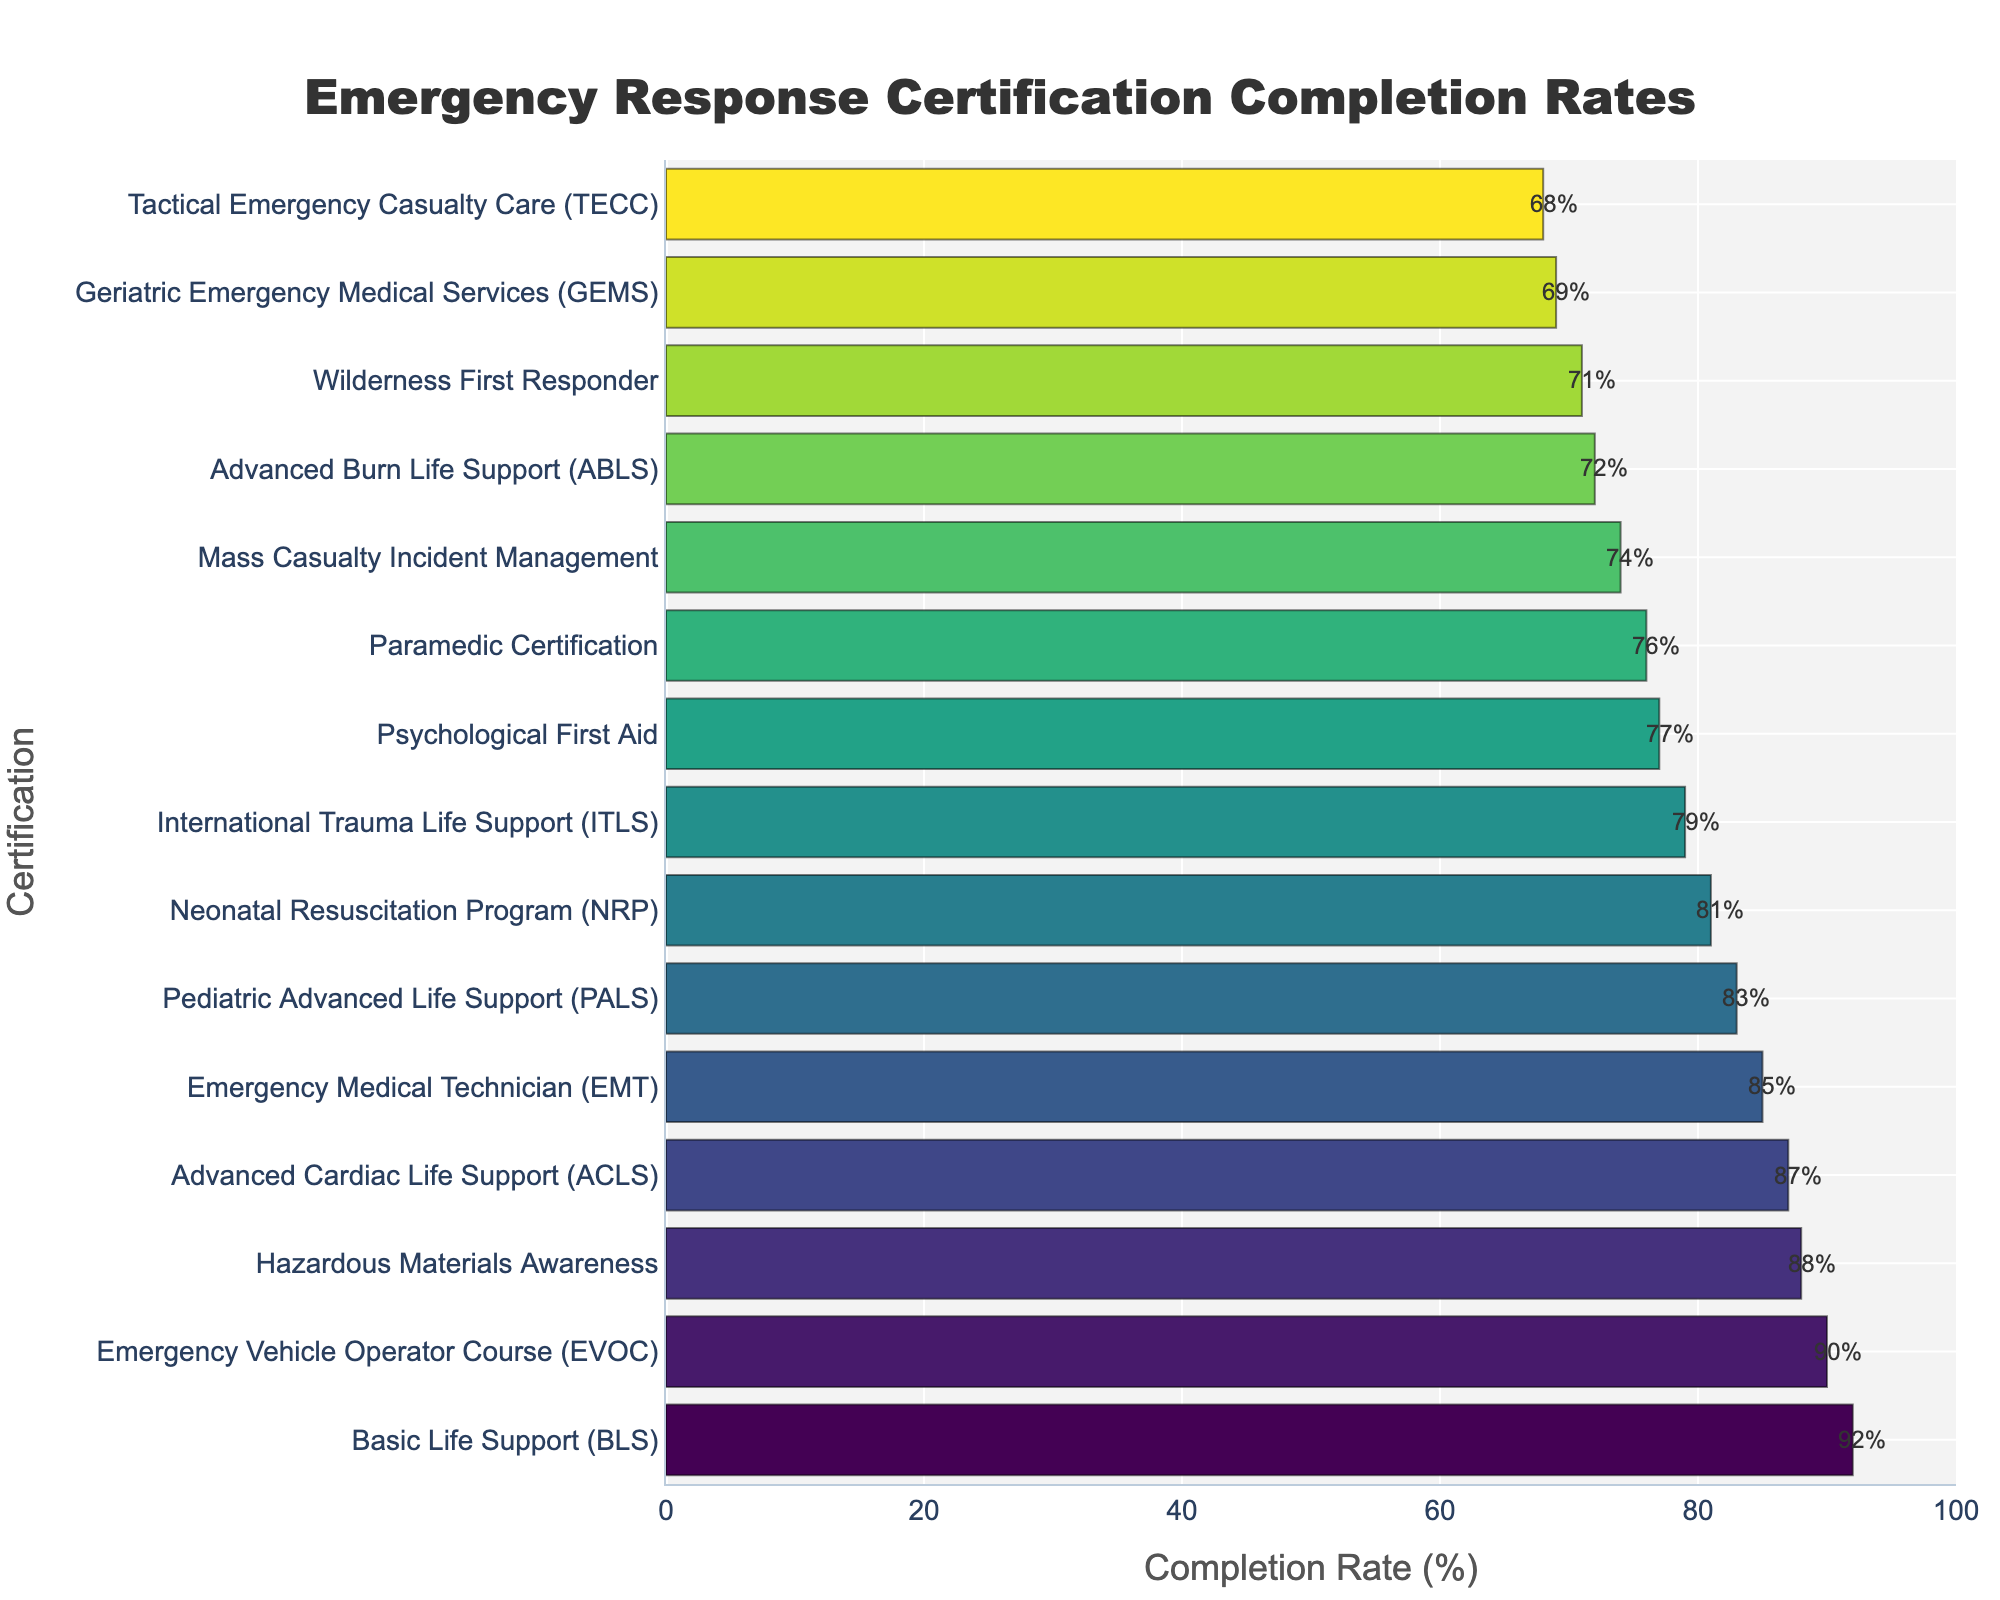Which certification has the highest completion rate? Look at the bar chart and identify the certification with the longest bar.
Answer: Basic Life Support (BLS) Which certification has the lowest completion rate? Look at the bar chart and identify the certification with the shortest bar.
Answer: Tactical Emergency Casualty Care (TECC) How much higher is the completion rate for Basic Life Support (BLS) compared to Tactical Emergency Casualty Care (TECC)? Subtract the completion rate of TECC from the completion rate of BLS: 92 - 68.
Answer: 24 What is the average completion rate for certifications with a rate above 80%? Identify the certifications above 80%: BLS, ACLS, PALS, EMT, EVOC, Hazardous Materials Awareness. Sum their completion rates and divide by the number of certifications: (92 + 87 + 83 + 85 + 90 + 88) / 6.
Answer: 87.5 Which three certifications have completion rates closest to 75%? Identify the bars closest to 75% by visually scanning the chart: Mass Casualty Incident Management (74), Advanced Burn Life Support (72), and Paramedic Certification (76).
Answer: Mass Casualty Incident Management, Advanced Burn Life Support, Paramedic Certification Is the completion rate for Neonatal Resuscitation Program (NRP) higher or lower than the Emergency Vehicle Operator Course (EVOC)? Compare the lengths of the bars for NRP and EVOC; NRP's bar is shorter than EVOC's bar.
Answer: Lower Which two certifications have completion rates closest to each other? Look for pairs of bars with similar lengths and values; Geriatric Emergency Medical Services (GEMS) at 69% and Tactical Emergency Casualty Care (TECC) at 68%.
Answer: Geriatric Emergency Medical Services, Tactical Emergency Casualty Care What is the difference in completion rates between Pediatric Advanced Life Support (PALS) and Mass Casualty Incident Management? Subtract the completion rate of Mass Casualty Incident Management from PALS: 83 - 74.
Answer: 9 How many certifications have a completion rate above 85%? Count the number of bars with values greater than 85%: BLS, ACLS, Hazardous Materials Awareness, and EVOC.
Answer: 4 What is the median completion rate of all certifications? Sort the completion rates, find the middle value(s): 92, 90, 88, 87, 85, 83, 81, 79, 77, 76, 74, 72, 71, 69, 68. The median is the average of the 7th and 8th values: (81+79)/2.
Answer: 80 